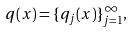<formula> <loc_0><loc_0><loc_500><loc_500>q ( x ) = \{ q _ { j } ( x ) \} _ { j = 1 } ^ { \infty } ,</formula> 